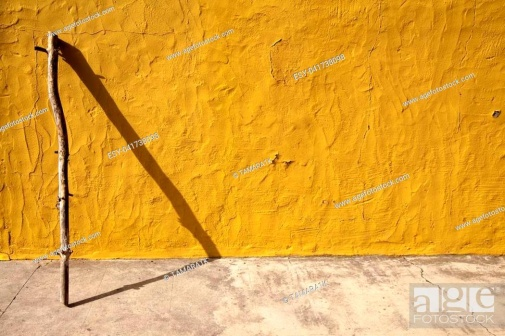Imagine this image is part of a dream. Describe the dream and its significance. In the dream, you find yourself in a vast, sunlit desert with endless horizons. Amidst this expanse stands a lone, ancient staff leaning against a brilliant yellow wall that seems to appear out of nowhere. The staff feels familiar, as if it once belonged to you in a different time. As you approach, the shadow of the staff grows longer, reaching out towards you. Touching the staff, you’re suddenly flooded with memories of travels, hardships, and joys, realizing that the staff represents your own life’s journey. This dream signifies a moment of introspection, urging you to reflect on your past while finding peace in your present solitude. In a more realistic scenario, what would you speculate about the location of this image? This image might be taken in a rural, rustic location, perhaps an old village where simplicity and minimalism are prominent. The textured yellow wall suggests a traditional plaster finish, common in countryside homes that have withstood the test of time. The ground seems to be made of concrete or stone, indicating an outdoor setting, possibly near a courtyard or a boundary wall of a home where the stick was casually left to rest. Give a short, realistic description of what might be just outside the frame of this image. Just outside the frame, there might be a quaint, sun-drenched yard with a few scattered wildflowers and patches of grass. Perhaps, there's an old wooden bench under the shade of a tree, where someone sits reflecting on their day. A rustic home with a similarly vibrant façade might be nearby, surrounded by the serene sounds of birds chirping and leaves rustling in the gentle breeze. 